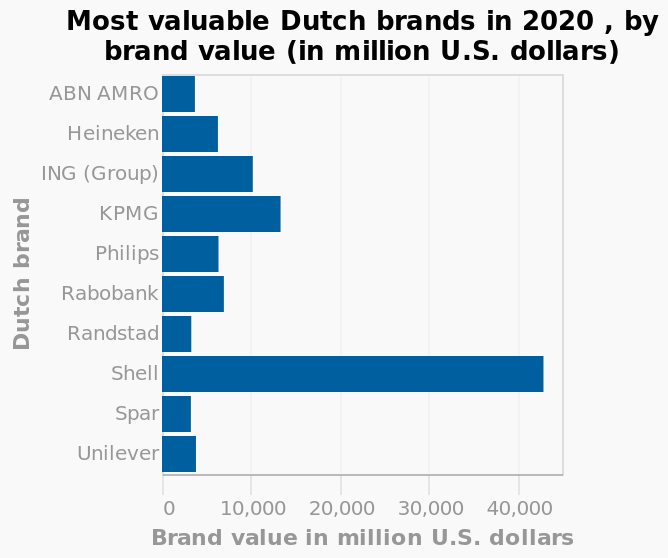<image>
What is the range of the x-axis in the chart? The range of the x-axis in the chart is from 0 to 40,000 using a linear scale. please describe the details of the chart This is a bar chart named Most valuable Dutch brands in 2020 , by brand value (in million U.S. dollars). The y-axis shows Dutch brand. Brand value in million U.S. dollars is defined using a linear scale of range 0 to 40,000 along the x-axis. Name one finance company that is among the most profitable in the Netherlands. KPMG is one of the finance companies that is among the most profitable in the Netherlands. 